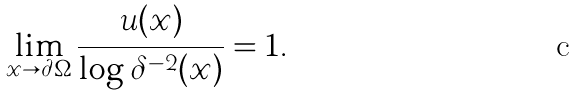Convert formula to latex. <formula><loc_0><loc_0><loc_500><loc_500>\lim _ { x \to \partial \Omega } \frac { u ( x ) } { \log \delta ^ { - 2 } ( x ) } = 1 .</formula> 